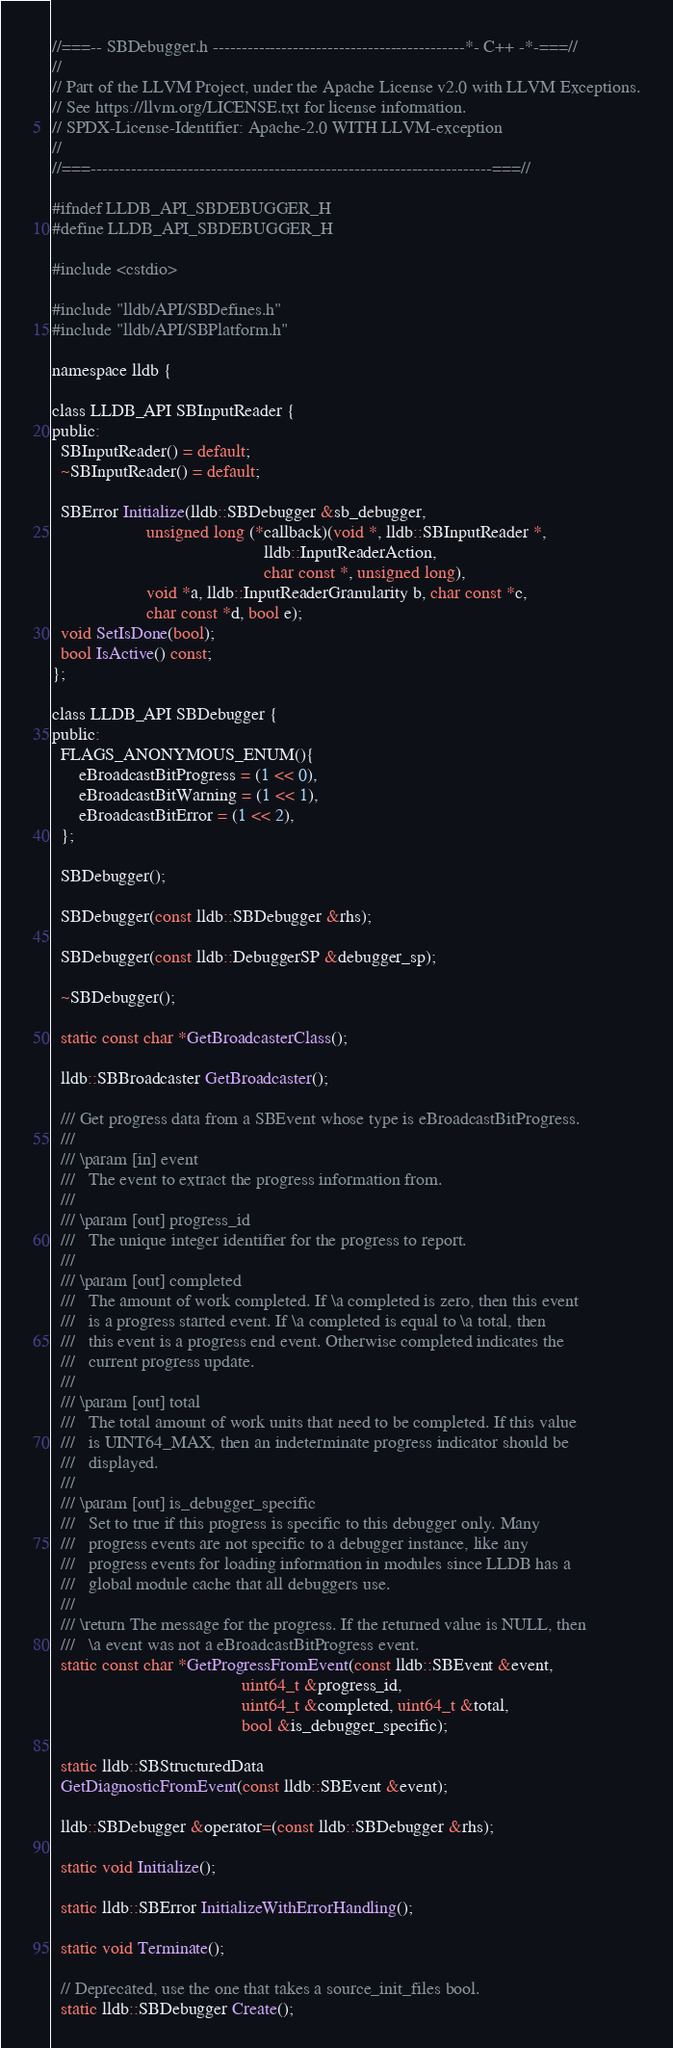Convert code to text. <code><loc_0><loc_0><loc_500><loc_500><_C_>//===-- SBDebugger.h --------------------------------------------*- C++ -*-===//
//
// Part of the LLVM Project, under the Apache License v2.0 with LLVM Exceptions.
// See https://llvm.org/LICENSE.txt for license information.
// SPDX-License-Identifier: Apache-2.0 WITH LLVM-exception
//
//===----------------------------------------------------------------------===//

#ifndef LLDB_API_SBDEBUGGER_H
#define LLDB_API_SBDEBUGGER_H

#include <cstdio>

#include "lldb/API/SBDefines.h"
#include "lldb/API/SBPlatform.h"

namespace lldb {

class LLDB_API SBInputReader {
public:
  SBInputReader() = default;
  ~SBInputReader() = default;

  SBError Initialize(lldb::SBDebugger &sb_debugger,
                     unsigned long (*callback)(void *, lldb::SBInputReader *,
                                               lldb::InputReaderAction,
                                               char const *, unsigned long),
                     void *a, lldb::InputReaderGranularity b, char const *c,
                     char const *d, bool e);
  void SetIsDone(bool);
  bool IsActive() const;
};

class LLDB_API SBDebugger {
public:
  FLAGS_ANONYMOUS_ENUM(){
      eBroadcastBitProgress = (1 << 0),
      eBroadcastBitWarning = (1 << 1),
      eBroadcastBitError = (1 << 2),
  };

  SBDebugger();

  SBDebugger(const lldb::SBDebugger &rhs);

  SBDebugger(const lldb::DebuggerSP &debugger_sp);

  ~SBDebugger();

  static const char *GetBroadcasterClass();

  lldb::SBBroadcaster GetBroadcaster();

  /// Get progress data from a SBEvent whose type is eBroadcastBitProgress.
  ///
  /// \param [in] event
  ///   The event to extract the progress information from.
  ///
  /// \param [out] progress_id
  ///   The unique integer identifier for the progress to report.
  ///
  /// \param [out] completed
  ///   The amount of work completed. If \a completed is zero, then this event
  ///   is a progress started event. If \a completed is equal to \a total, then
  ///   this event is a progress end event. Otherwise completed indicates the
  ///   current progress update.
  ///
  /// \param [out] total
  ///   The total amount of work units that need to be completed. If this value
  ///   is UINT64_MAX, then an indeterminate progress indicator should be
  ///   displayed.
  ///
  /// \param [out] is_debugger_specific
  ///   Set to true if this progress is specific to this debugger only. Many
  ///   progress events are not specific to a debugger instance, like any
  ///   progress events for loading information in modules since LLDB has a
  ///   global module cache that all debuggers use.
  ///
  /// \return The message for the progress. If the returned value is NULL, then
  ///   \a event was not a eBroadcastBitProgress event.
  static const char *GetProgressFromEvent(const lldb::SBEvent &event,
                                          uint64_t &progress_id,
                                          uint64_t &completed, uint64_t &total,
                                          bool &is_debugger_specific);

  static lldb::SBStructuredData
  GetDiagnosticFromEvent(const lldb::SBEvent &event);

  lldb::SBDebugger &operator=(const lldb::SBDebugger &rhs);

  static void Initialize();

  static lldb::SBError InitializeWithErrorHandling();

  static void Terminate();

  // Deprecated, use the one that takes a source_init_files bool.
  static lldb::SBDebugger Create();
</code> 